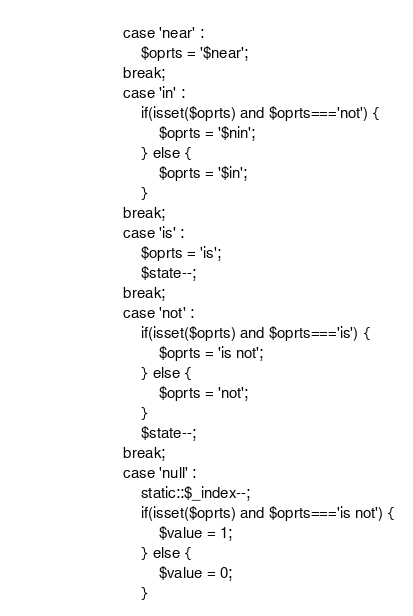<code> <loc_0><loc_0><loc_500><loc_500><_PHP_>						case 'near' :
							$oprts = '$near';
						break;
						case 'in' :
							if(isset($oprts) and $oprts==='not') {
								$oprts = '$nin';
							} else {
								$oprts = '$in';
							}
						break;
						case 'is' :
							$oprts = 'is';
							$state--;
						break;
						case 'not' :
							if(isset($oprts) and $oprts==='is') {
								$oprts = 'is not';
							} else {
								$oprts = 'not';
							}
							$state--;
						break;
						case 'null' :
							static::$_index--;
							if(isset($oprts) and $oprts==='is not') {
								$value = 1;
							} else {
								$value = 0;
							}</code> 